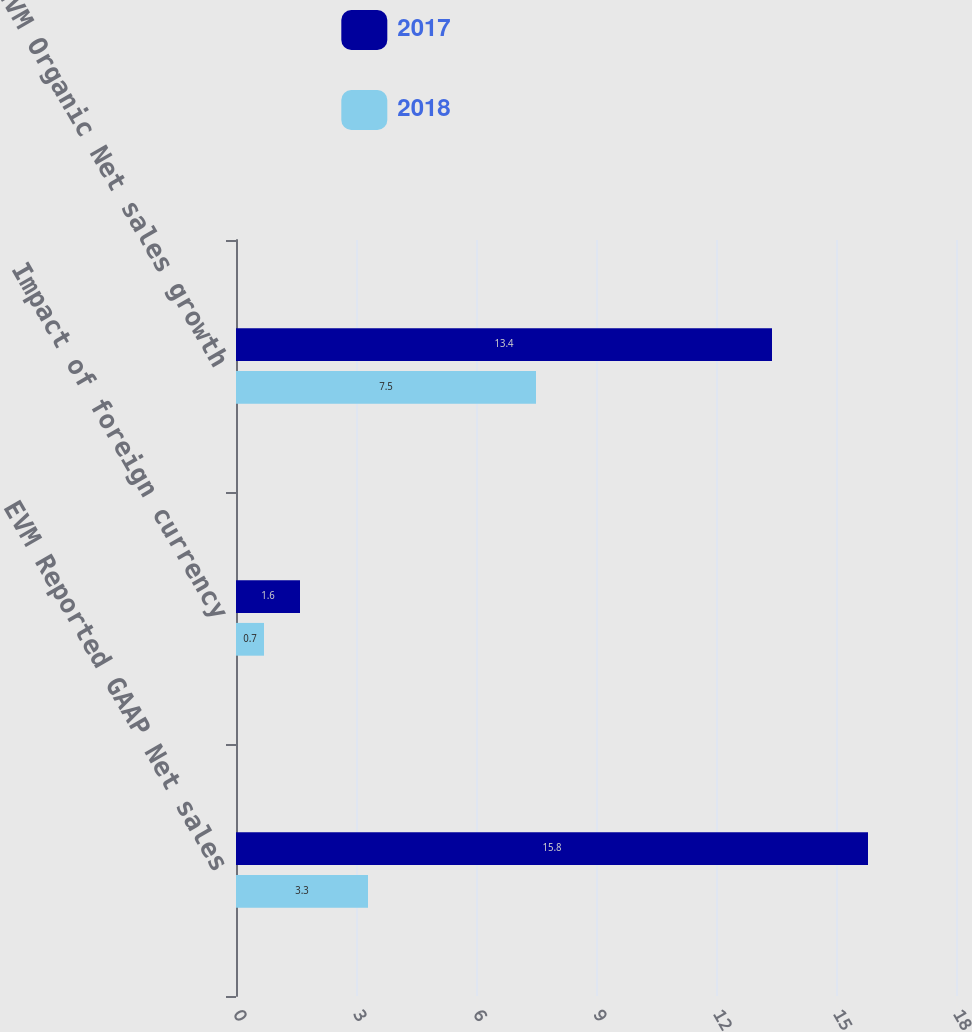<chart> <loc_0><loc_0><loc_500><loc_500><stacked_bar_chart><ecel><fcel>EVM Reported GAAP Net sales<fcel>Impact of foreign currency<fcel>EVM Organic Net sales growth<nl><fcel>2017<fcel>15.8<fcel>1.6<fcel>13.4<nl><fcel>2018<fcel>3.3<fcel>0.7<fcel>7.5<nl></chart> 